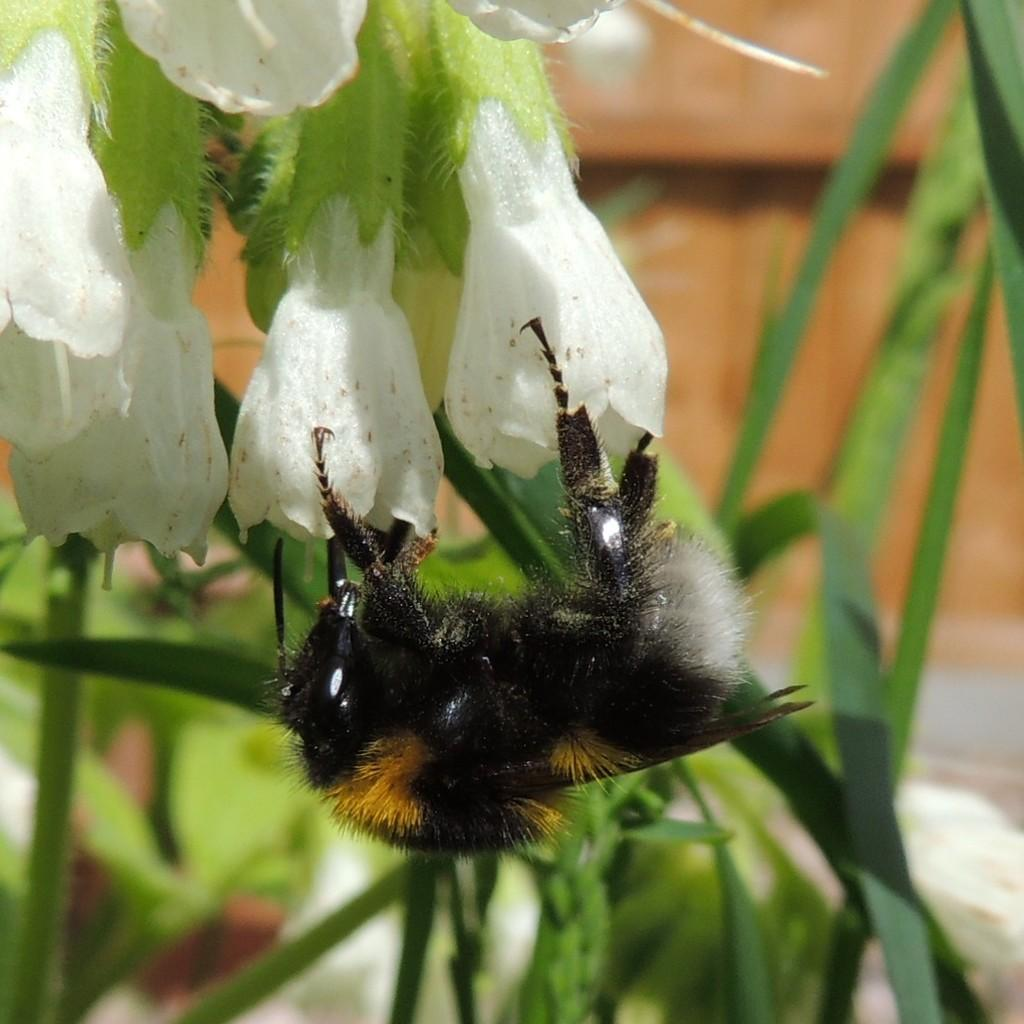What type of insect is in the image? There is a black color insect in the image. What is the insect doing or where is it located? The insect is on red color flowers. What can be seen in the background of the image? There is grass visible in the background of the image. What type of meat is hanging from the branches of the red color flowers in the image? There is no meat present in the image; it features a black color insect on red color flowers. How many sticks are visible in the image? There are no sticks visible in the image. 